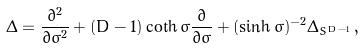<formula> <loc_0><loc_0><loc_500><loc_500>\Delta = \frac { \partial ^ { 2 } } { \partial \sigma ^ { 2 } } + ( D - 1 ) \coth \sigma \frac { \partial } { \partial \sigma } + ( \sinh \sigma ) ^ { - 2 } \Delta _ { S ^ { D - 1 } } \, ,</formula> 